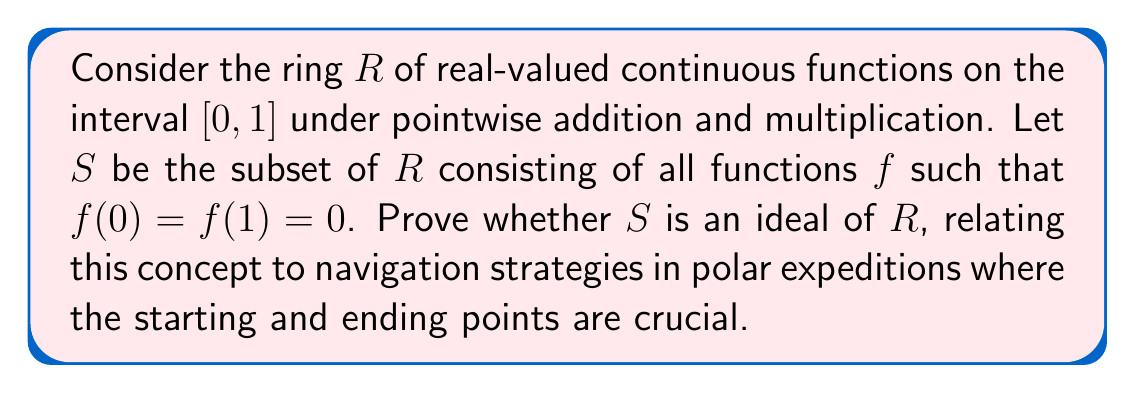Can you solve this math problem? To prove whether $S$ is an ideal of $R$, we need to check three conditions:

1. $S$ is non-empty
2. $S$ is closed under addition
3. $S$ is closed under multiplication by elements of $R$

Let's verify each condition:

1. Non-emptiness:
   The zero function $f(x) = 0$ for all $x \in [0, 1]$ is in $S$, so $S$ is non-empty.

2. Closure under addition:
   Let $f, g \in S$. Then $(f + g)(0) = f(0) + g(0) = 0 + 0 = 0$ and $(f + g)(1) = f(1) + g(1) = 0 + 0 = 0$. Therefore, $f + g \in S$.

3. Closure under multiplication by ring elements:
   Let $f \in S$ and $r \in R$. Then $(rf)(0) = r(0)f(0) = r(0) \cdot 0 = 0$ and $(rf)(1) = r(1)f(1) = r(1) \cdot 0 = 0$. Therefore, $rf \in S$.

All three conditions are satisfied, so $S$ is indeed an ideal of $R$.

Relating to navigation strategies:
In polar expeditions, the concept of an ideal can be likened to a set of navigation strategies where the starting point (0) and ending point (1) are fixed. The closure under addition represents combining different strategies, while closure under multiplication by ring elements represents scaling or modifying strategies based on external factors (like weather conditions). The fact that $S$ forms an ideal ensures that any combination or modification of these strategies will always result in a valid strategy that begins and ends at the predetermined points, just as Roald Amundsen meticulously planned his expeditions with fixed starting and ending locations.
Answer: $S$ is an ideal of $R$. 